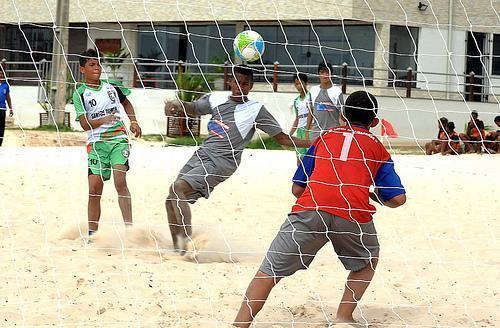How many children are playing?
Give a very brief answer. 5. 